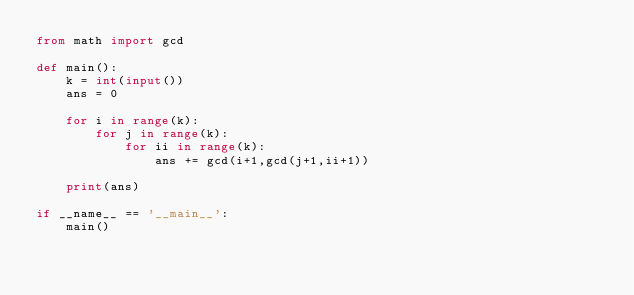Convert code to text. <code><loc_0><loc_0><loc_500><loc_500><_Python_>from math import gcd
 
def main():
    k = int(input())
    ans = 0
 
    for i in range(k):
        for j in range(k):
            for ii in range(k):
                ans += gcd(i+1,gcd(j+1,ii+1))
 
    print(ans)
 
if __name__ == '__main__':
    main()</code> 